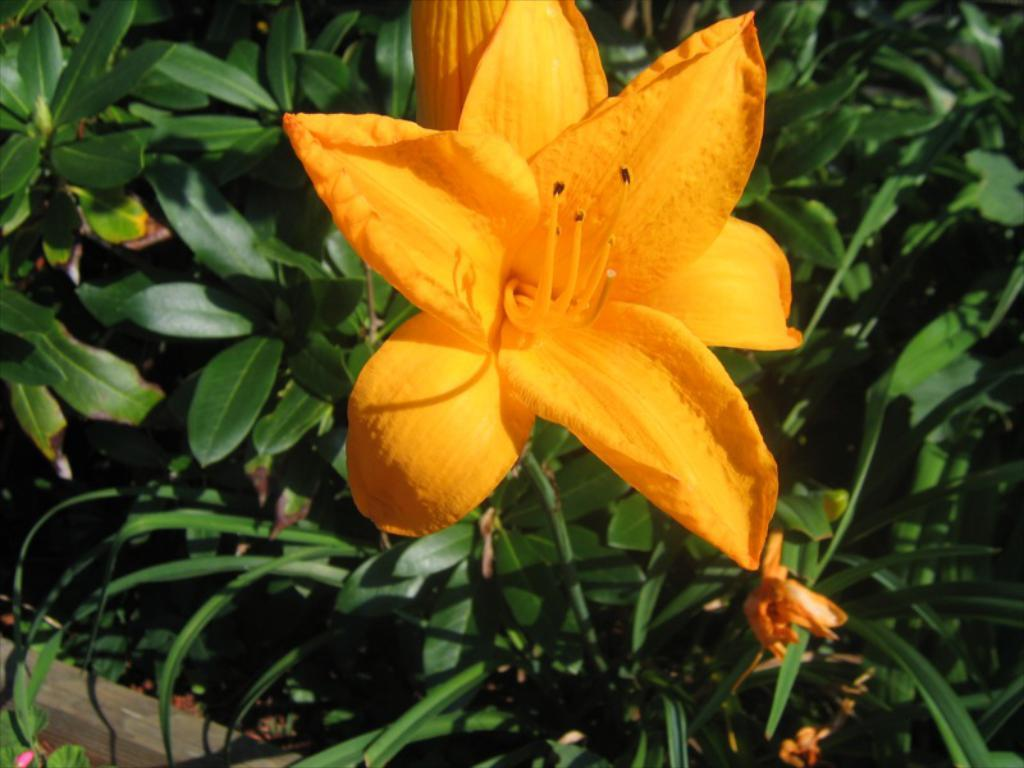What type of living organisms can be seen in the image? There are flowers and plants in the image. Can you describe the object in the bottom left corner of the image? Unfortunately, the provided facts do not give any information about the object in the bottom left corner of the image. What is the primary focus of the image? The primary focus of the image is the flowers and plants. What time does the clock in the image show? There is no clock present in the image, so it is not possible to determine the time. 